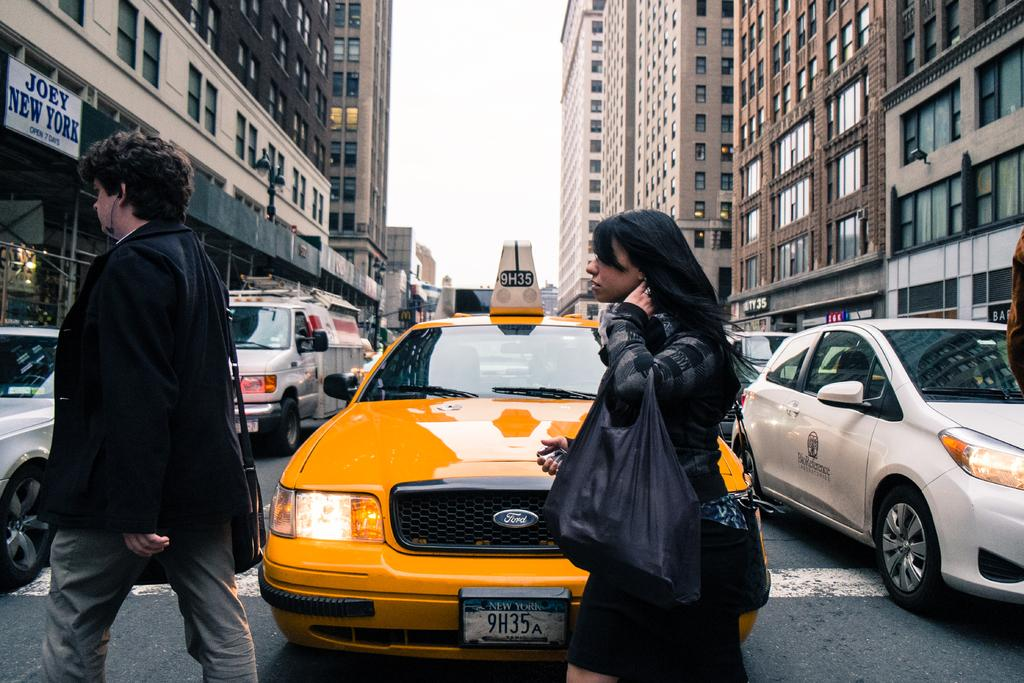<image>
Describe the image concisely. A woman walks past a taxi with 9H35 on its license plate. 